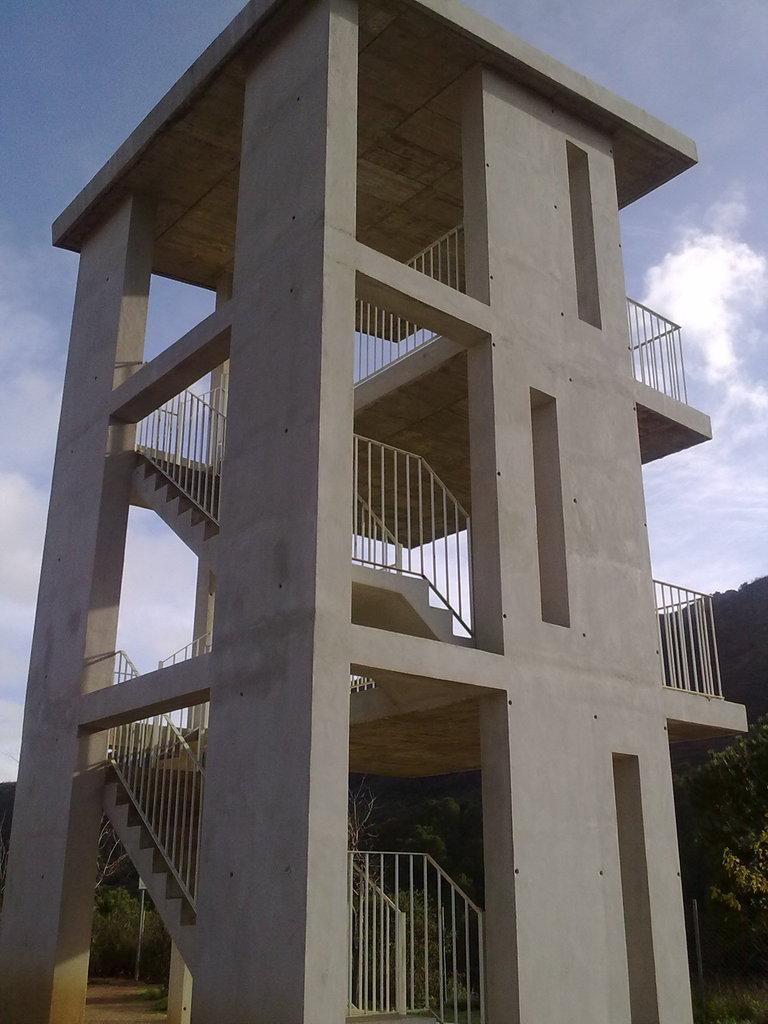What type of structure is visible in the image? There is a building in the image. What feature of the building is mentioned in the facts? The building has staircases and a stair railing. What can be seen on the right side of the image? There are trees on the right side of the image. What is visible in the background of the image? The sky is visible in the background of the image, and there are clouds in the sky. What type of operation is taking place in the church depicted in the image? There is no church or operation present in the image; it features a building with staircases and trees on the right side. What color is the lipstick worn by the person in the image? There is no person or lipstick present in the image. 